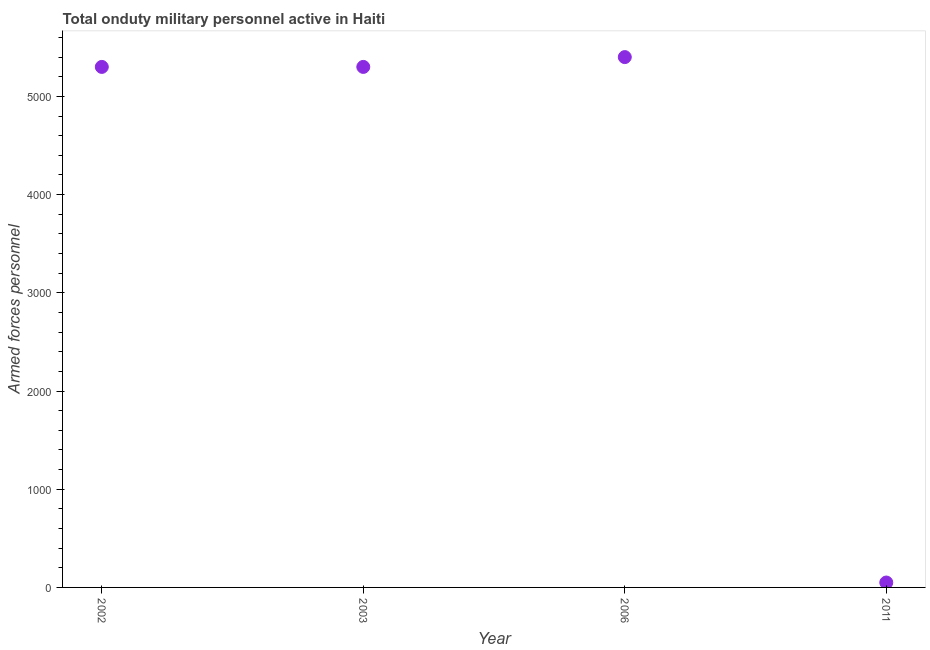What is the number of armed forces personnel in 2006?
Give a very brief answer. 5400. Across all years, what is the maximum number of armed forces personnel?
Your answer should be compact. 5400. Across all years, what is the minimum number of armed forces personnel?
Your response must be concise. 50. In which year was the number of armed forces personnel minimum?
Ensure brevity in your answer.  2011. What is the sum of the number of armed forces personnel?
Your answer should be compact. 1.60e+04. What is the difference between the number of armed forces personnel in 2002 and 2006?
Provide a short and direct response. -100. What is the average number of armed forces personnel per year?
Offer a terse response. 4012.5. What is the median number of armed forces personnel?
Ensure brevity in your answer.  5300. What is the ratio of the number of armed forces personnel in 2002 to that in 2011?
Provide a succinct answer. 106. Is the number of armed forces personnel in 2002 less than that in 2006?
Offer a very short reply. Yes. Is the difference between the number of armed forces personnel in 2003 and 2006 greater than the difference between any two years?
Provide a short and direct response. No. What is the difference between the highest and the lowest number of armed forces personnel?
Your response must be concise. 5350. Does the number of armed forces personnel monotonically increase over the years?
Keep it short and to the point. No. How many dotlines are there?
Keep it short and to the point. 1. Are the values on the major ticks of Y-axis written in scientific E-notation?
Offer a terse response. No. What is the title of the graph?
Your response must be concise. Total onduty military personnel active in Haiti. What is the label or title of the Y-axis?
Make the answer very short. Armed forces personnel. What is the Armed forces personnel in 2002?
Offer a terse response. 5300. What is the Armed forces personnel in 2003?
Offer a terse response. 5300. What is the Armed forces personnel in 2006?
Your answer should be very brief. 5400. What is the Armed forces personnel in 2011?
Your answer should be compact. 50. What is the difference between the Armed forces personnel in 2002 and 2003?
Provide a short and direct response. 0. What is the difference between the Armed forces personnel in 2002 and 2006?
Provide a short and direct response. -100. What is the difference between the Armed forces personnel in 2002 and 2011?
Your answer should be compact. 5250. What is the difference between the Armed forces personnel in 2003 and 2006?
Provide a short and direct response. -100. What is the difference between the Armed forces personnel in 2003 and 2011?
Your answer should be very brief. 5250. What is the difference between the Armed forces personnel in 2006 and 2011?
Provide a short and direct response. 5350. What is the ratio of the Armed forces personnel in 2002 to that in 2006?
Offer a very short reply. 0.98. What is the ratio of the Armed forces personnel in 2002 to that in 2011?
Keep it short and to the point. 106. What is the ratio of the Armed forces personnel in 2003 to that in 2006?
Give a very brief answer. 0.98. What is the ratio of the Armed forces personnel in 2003 to that in 2011?
Your response must be concise. 106. What is the ratio of the Armed forces personnel in 2006 to that in 2011?
Provide a short and direct response. 108. 